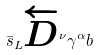Convert formula to latex. <formula><loc_0><loc_0><loc_500><loc_500>\bar { s } _ { L } \overleftarrow { D } ^ { \nu } \gamma ^ { \alpha } b</formula> 